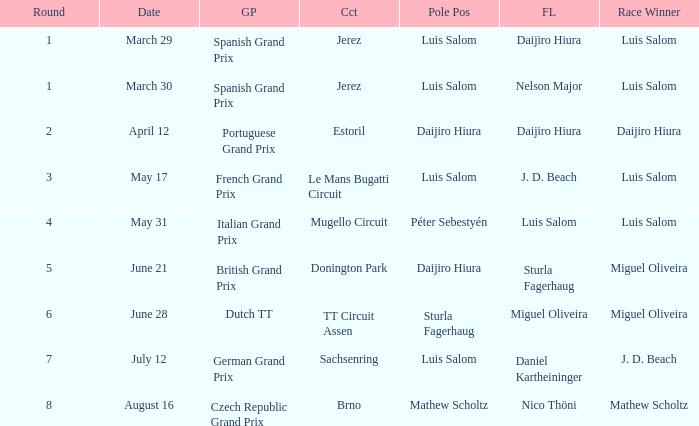Who had the fastest lap in the Dutch TT Grand Prix?  Miguel Oliveira. 